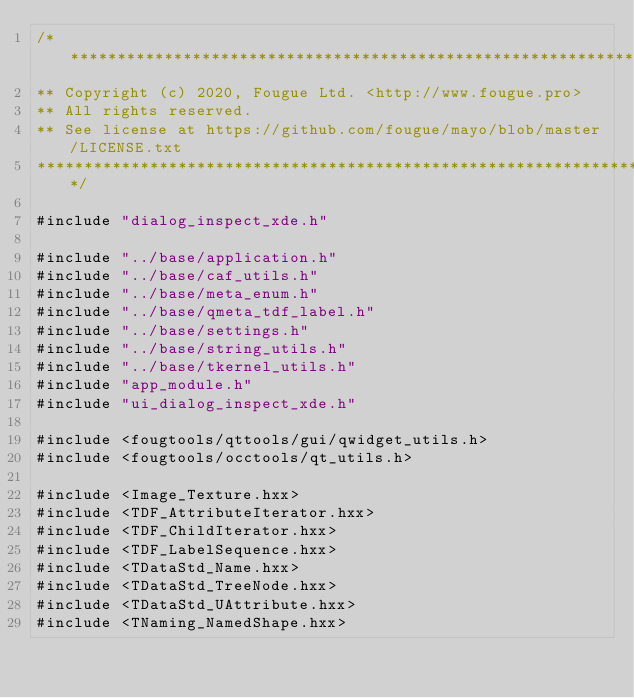<code> <loc_0><loc_0><loc_500><loc_500><_C++_>/****************************************************************************
** Copyright (c) 2020, Fougue Ltd. <http://www.fougue.pro>
** All rights reserved.
** See license at https://github.com/fougue/mayo/blob/master/LICENSE.txt
****************************************************************************/

#include "dialog_inspect_xde.h"

#include "../base/application.h"
#include "../base/caf_utils.h"
#include "../base/meta_enum.h"
#include "../base/qmeta_tdf_label.h"
#include "../base/settings.h"
#include "../base/string_utils.h"
#include "../base/tkernel_utils.h"
#include "app_module.h"
#include "ui_dialog_inspect_xde.h"

#include <fougtools/qttools/gui/qwidget_utils.h>
#include <fougtools/occtools/qt_utils.h>

#include <Image_Texture.hxx>
#include <TDF_AttributeIterator.hxx>
#include <TDF_ChildIterator.hxx>
#include <TDF_LabelSequence.hxx>
#include <TDataStd_Name.hxx>
#include <TDataStd_TreeNode.hxx>
#include <TDataStd_UAttribute.hxx>
#include <TNaming_NamedShape.hxx></code> 